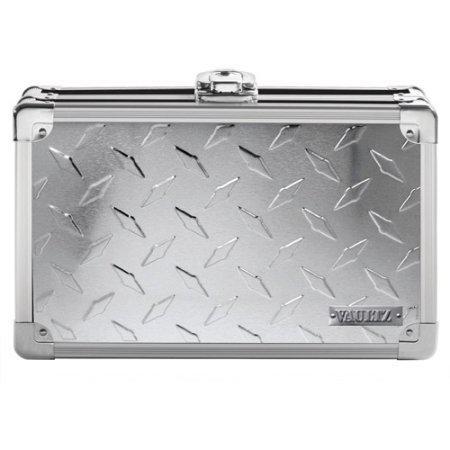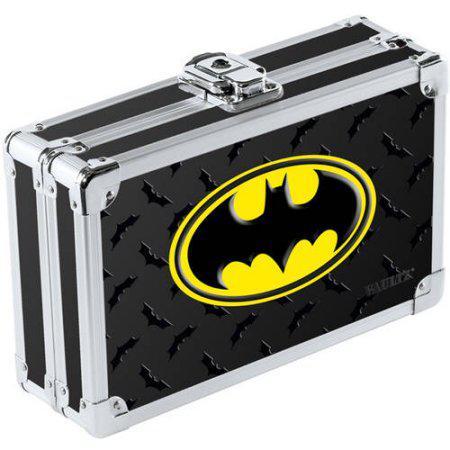The first image is the image on the left, the second image is the image on the right. For the images displayed, is the sentence "In one of the images there is a suitcase that is sitting at a 45 degree angle." factually correct? Answer yes or no. Yes. The first image is the image on the left, the second image is the image on the right. Analyze the images presented: Is the assertion "There is a batman logo." valid? Answer yes or no. Yes. 